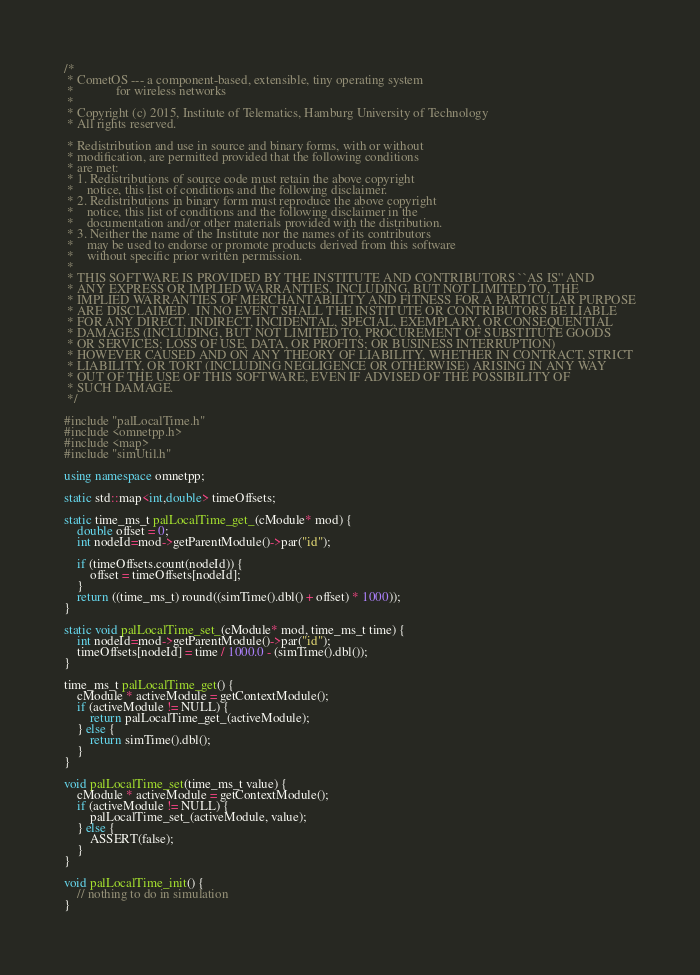Convert code to text. <code><loc_0><loc_0><loc_500><loc_500><_C++_>/*
 * CometOS --- a component-based, extensible, tiny operating system
 *             for wireless networks
 *
 * Copyright (c) 2015, Institute of Telematics, Hamburg University of Technology
 * All rights reserved.

 * Redistribution and use in source and binary forms, with or without
 * modification, are permitted provided that the following conditions
 * are met:
 * 1. Redistributions of source code must retain the above copyright
 *    notice, this list of conditions and the following disclaimer.
 * 2. Redistributions in binary form must reproduce the above copyright
 *    notice, this list of conditions and the following disclaimer in the
 *    documentation and/or other materials provided with the distribution.
 * 3. Neither the name of the Institute nor the names of its contributors
 *    may be used to endorse or promote products derived from this software
 *    without specific prior written permission.
 *
 * THIS SOFTWARE IS PROVIDED BY THE INSTITUTE AND CONTRIBUTORS ``AS IS'' AND
 * ANY EXPRESS OR IMPLIED WARRANTIES, INCLUDING, BUT NOT LIMITED TO, THE
 * IMPLIED WARRANTIES OF MERCHANTABILITY AND FITNESS FOR A PARTICULAR PURPOSE
 * ARE DISCLAIMED.  IN NO EVENT SHALL THE INSTITUTE OR CONTRIBUTORS BE LIABLE
 * FOR ANY DIRECT, INDIRECT, INCIDENTAL, SPECIAL, EXEMPLARY, OR CONSEQUENTIAL
 * DAMAGES (INCLUDING, BUT NOT LIMITED TO, PROCUREMENT OF SUBSTITUTE GOODS
 * OR SERVICES; LOSS OF USE, DATA, OR PROFITS; OR BUSINESS INTERRUPTION)
 * HOWEVER CAUSED AND ON ANY THEORY OF LIABILITY, WHETHER IN CONTRACT, STRICT
 * LIABILITY, OR TORT (INCLUDING NEGLIGENCE OR OTHERWISE) ARISING IN ANY WAY
 * OUT OF THE USE OF THIS SOFTWARE, EVEN IF ADVISED OF THE POSSIBILITY OF
 * SUCH DAMAGE.
 */

#include "palLocalTime.h"
#include <omnetpp.h>
#include <map>
#include "simUtil.h"

using namespace omnetpp;

static std::map<int,double> timeOffsets;

static time_ms_t palLocalTime_get_(cModule* mod) {
    double offset = 0;
    int nodeId=mod->getParentModule()->par("id");

    if (timeOffsets.count(nodeId)) {
        offset = timeOffsets[nodeId];
    }
    return ((time_ms_t) round((simTime().dbl() + offset) * 1000));
}

static void palLocalTime_set_(cModule* mod, time_ms_t time) {
    int nodeId=mod->getParentModule()->par("id");
    timeOffsets[nodeId] = time / 1000.0 - (simTime().dbl());
}

time_ms_t palLocalTime_get() {
    cModule * activeModule = getContextModule();
    if (activeModule != NULL) {
        return palLocalTime_get_(activeModule);
    } else {
        return simTime().dbl();
    }
}

void palLocalTime_set(time_ms_t value) {
    cModule * activeModule = getContextModule();
    if (activeModule != NULL) {
        palLocalTime_set_(activeModule, value);
    } else {
        ASSERT(false);
    }
}

void palLocalTime_init() {
    // nothing to do in simulation
}





</code> 